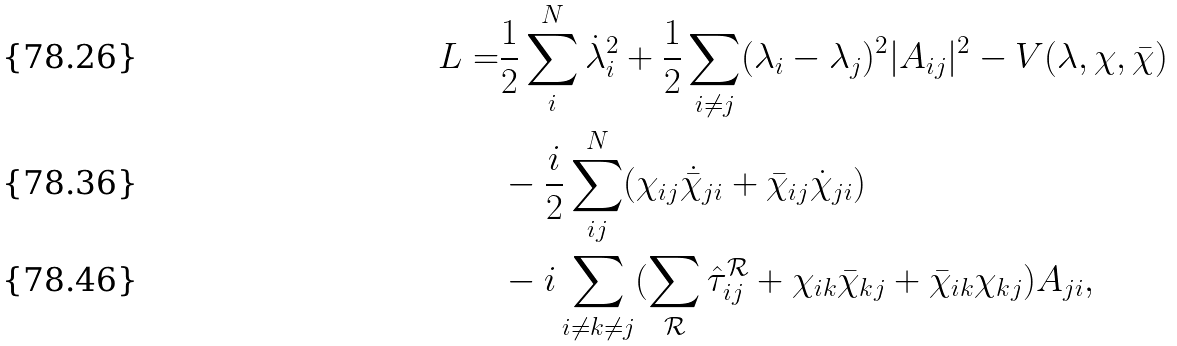Convert formula to latex. <formula><loc_0><loc_0><loc_500><loc_500>L = & \frac { 1 } { 2 } \sum _ { i } ^ { N } \dot { \lambda } ^ { 2 } _ { i } + \frac { 1 } { 2 } \sum _ { i \neq j } ( \lambda _ { i } - \lambda _ { j } ) ^ { 2 } | A _ { i j } | ^ { 2 } - V ( \lambda , \chi , \bar { \chi } ) \\ & - \frac { i } { 2 } \sum _ { i j } ^ { N } ( \chi _ { i j } \dot { \bar { \chi } } _ { j i } + \bar { \chi } _ { i j } \dot { \chi } _ { j i } ) \\ & - i \sum _ { i \neq k \neq j } ( \sum _ { \mathcal { R } } \hat { \tau } ^ { \mathcal { R } } _ { i j } + \chi _ { i k } \bar { \chi } _ { k j } + \bar { \chi } _ { i k } \chi _ { k j } ) A _ { j i } ,</formula> 